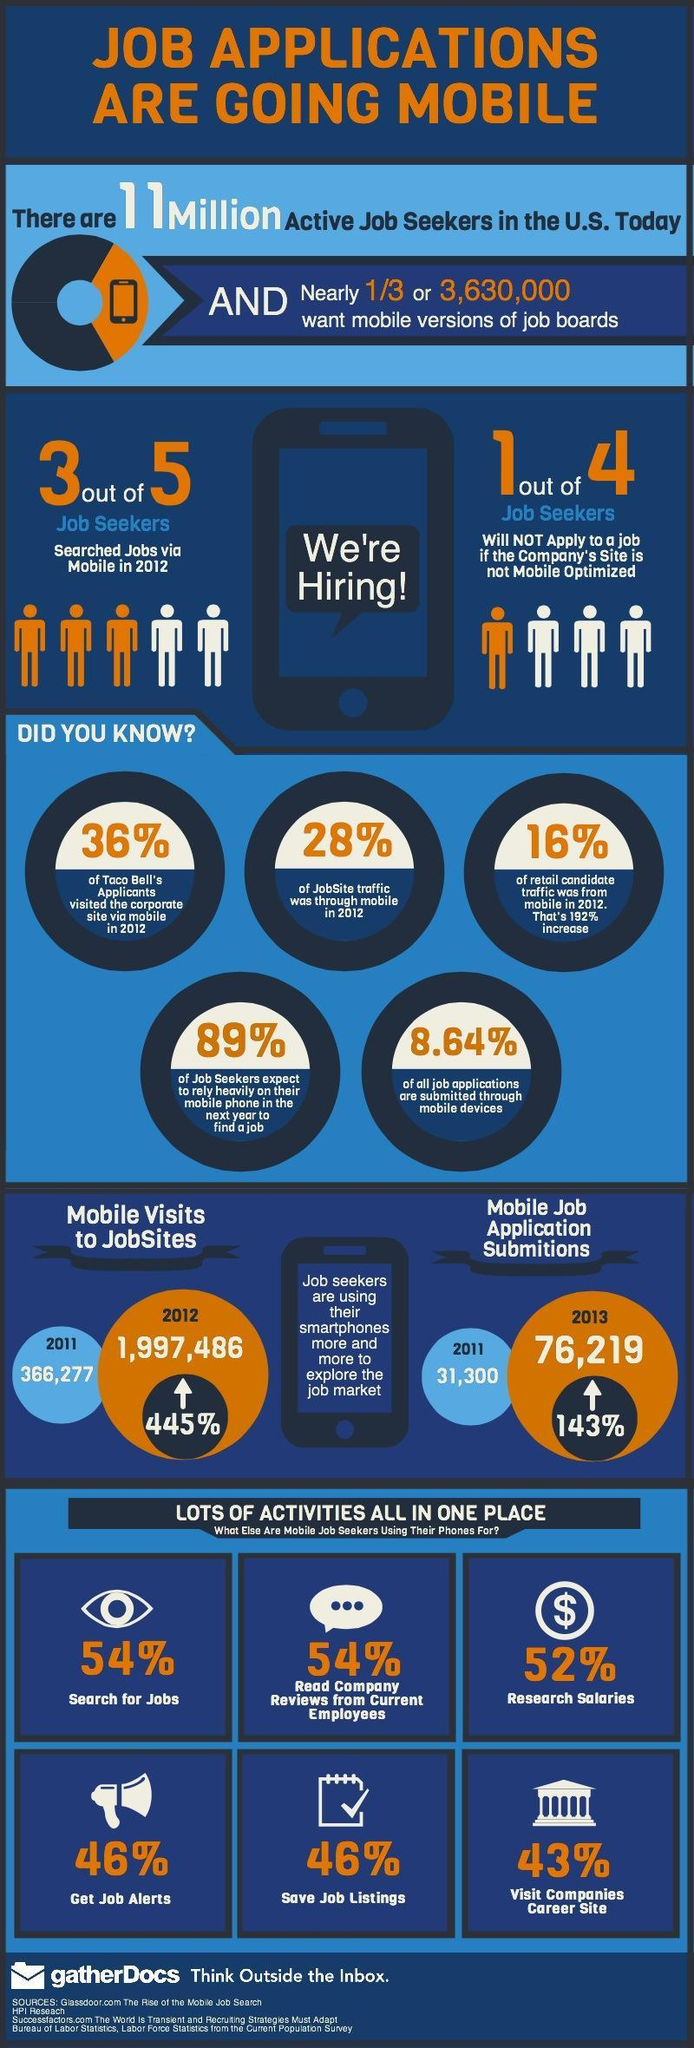What was the percentage increase in mobile visits to jobsites?
Answer the question with a short phrase. 445% What was the percentage increase in mobile job application submissions 2011-13? 143% What is the percentage of job applications submitted through mobile devices? 8.64% What was the rate of people seeking jobs via mobile in 2012? 3 out of 5 What did 43% of mobile job seekers use their phones for? visit companies career site What was the percentage of mobile traffic of Jobsite in 2012? 28% What did 52% of mobile job seekers use the phones for? research salaries What percentage of Taco Bell's applicants visited the site through mobile? 36% 